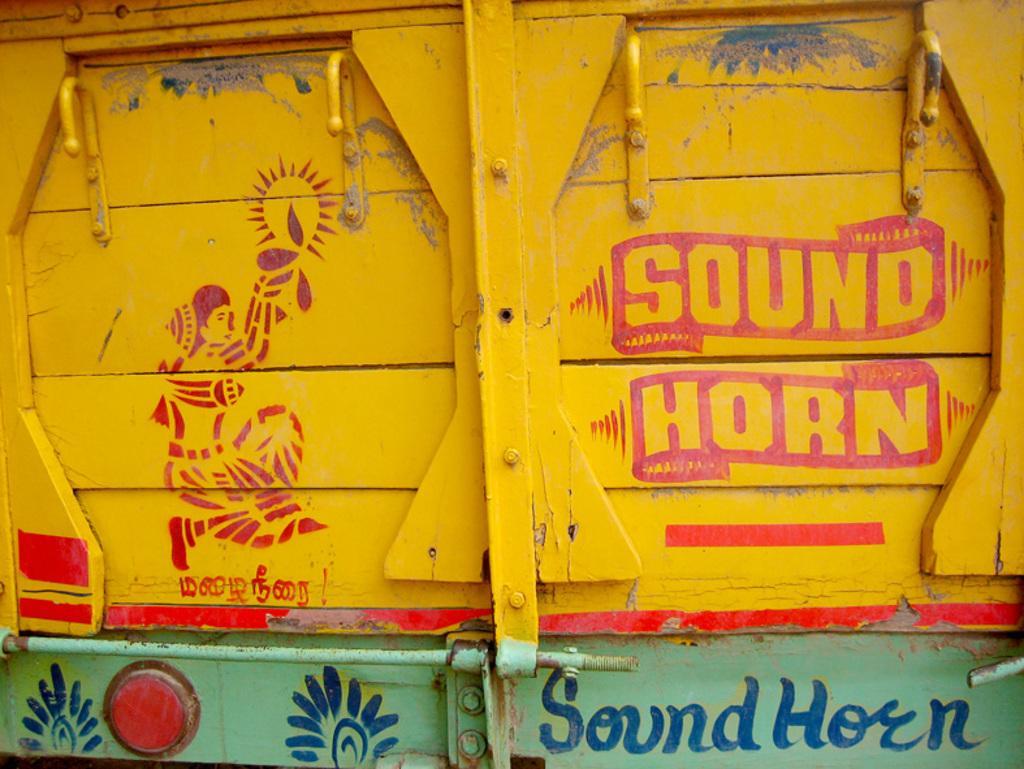Describe this image in one or two sentences. In this picture we can see the painting and some information on the wooden surface. We can see the hooks, bolt. This looks like the partial part of a vehicle. 